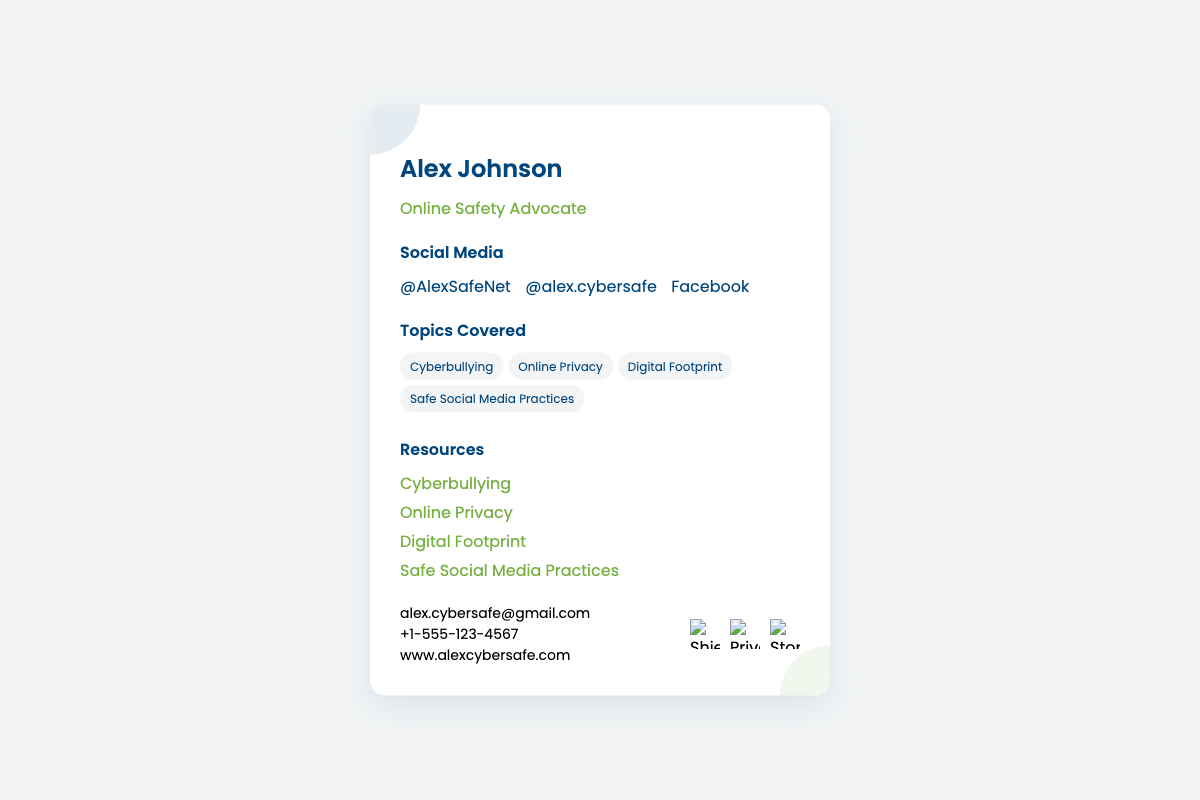What is the name of the advocate? The name of the advocate is found at the top of the document and is presented prominently.
Answer: Alex Johnson What topics are covered in this card? The topics covered are listed under the "Topics Covered" section and include several areas related to online safety.
Answer: Cyberbullying, Online Privacy, Digital Footprint, Safe Social Media Practices What is the email address for contact? The email address is provided in the "contact" section of the document.
Answer: alex.cybersafe@gmail.com How many social media handles are listed? The number of social media handles can be counted in the "Social Media" section.
Answer: 3 Which resource links are provided for Cyberbullying? The specific resource link for Cyberbullying is directly listed in the "Resources" section.
Answer: Cyberbullying What color scheme is used for the card? The color scheme can be inferred from the background, text, and section colors mentioned throughout the card design.
Answer: Secure color scheme What is the phone number listed? The phone number is found in the "contact" section and is clearly stated.
Answer: +1-555-123-4567 What is the purpose of this card? The purpose can be inferred from the title and subtitle at the top of the card.
Answer: Online Safety Advocate What icons are present in the contact section? The icons present are related to online safety, specifically indicated in the "icons" portion of the document.
Answer: Shield, Privacy, Stop Cyberbullying 